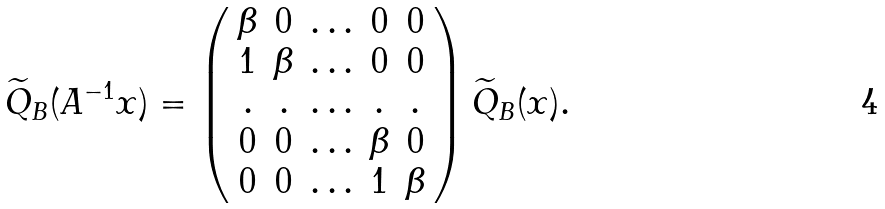Convert formula to latex. <formula><loc_0><loc_0><loc_500><loc_500>\widetilde { Q } _ { B } ( A ^ { - 1 } x ) = \left ( \begin{array} { c c c c c } \beta & 0 & \hdots & 0 & 0 \\ 1 & \beta & \hdots & 0 & 0 \\ . & . & \hdots & . & . \\ 0 & 0 & \hdots & \beta & 0 \\ 0 & 0 & \hdots & 1 & \beta \end{array} \right ) \widetilde { Q } _ { B } ( x ) .</formula> 